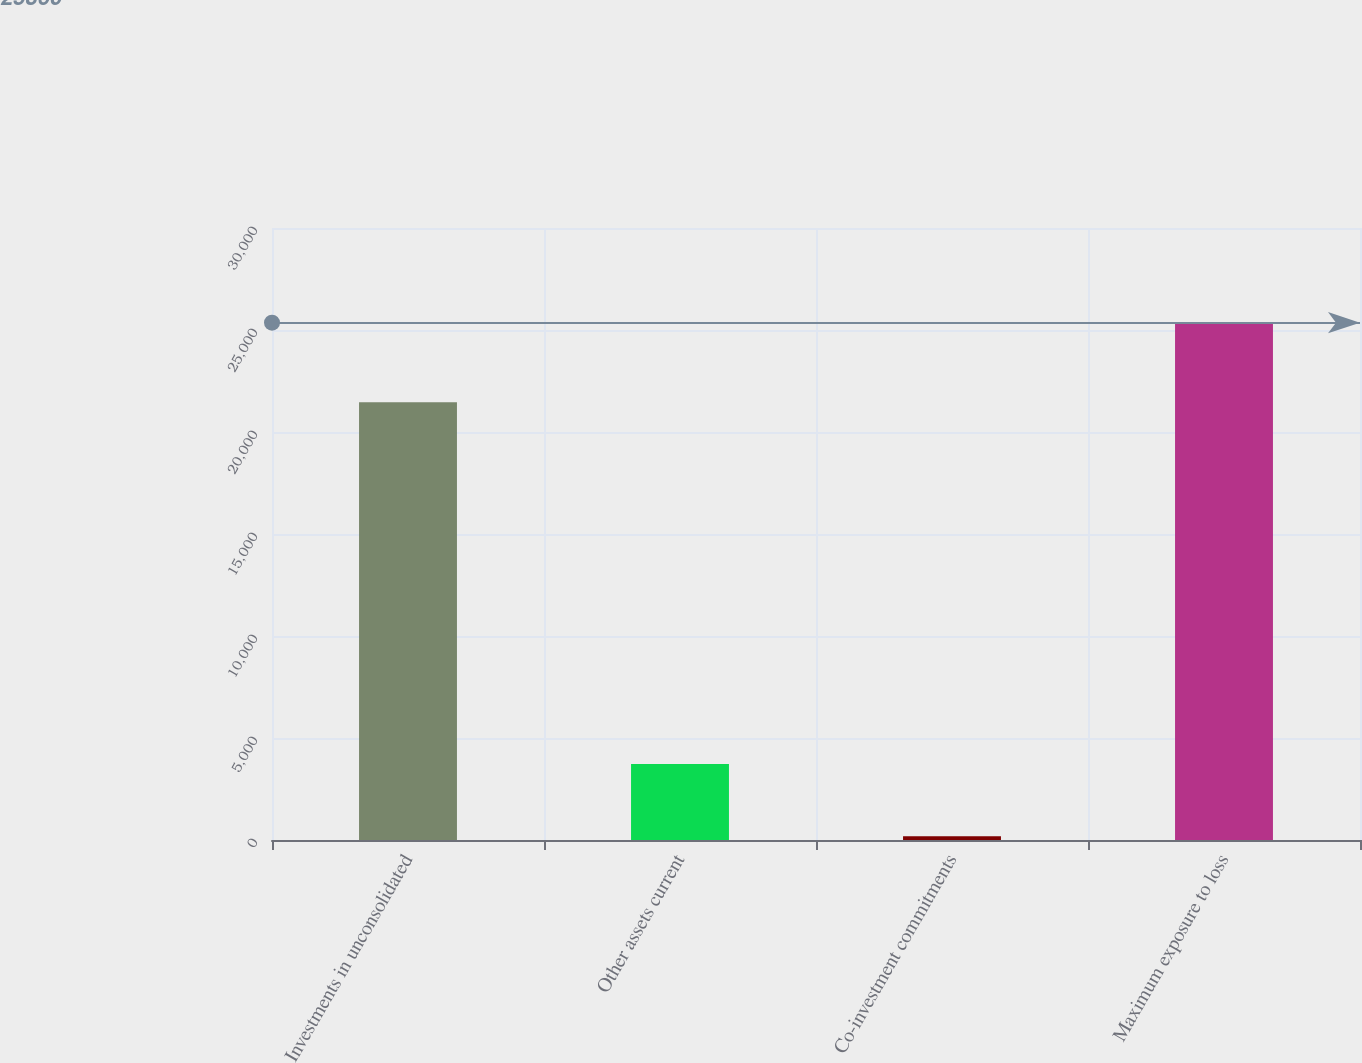Convert chart. <chart><loc_0><loc_0><loc_500><loc_500><bar_chart><fcel>Investments in unconsolidated<fcel>Other assets current<fcel>Co-investment commitments<fcel>Maximum exposure to loss<nl><fcel>21457<fcel>3723<fcel>180<fcel>25360<nl></chart> 